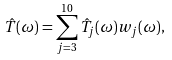<formula> <loc_0><loc_0><loc_500><loc_500>\hat { T } ( \omega ) = \sum _ { j = 3 } ^ { 1 0 } \hat { T _ { j } } ( \omega ) { w _ { j } } ( \omega ) ,</formula> 